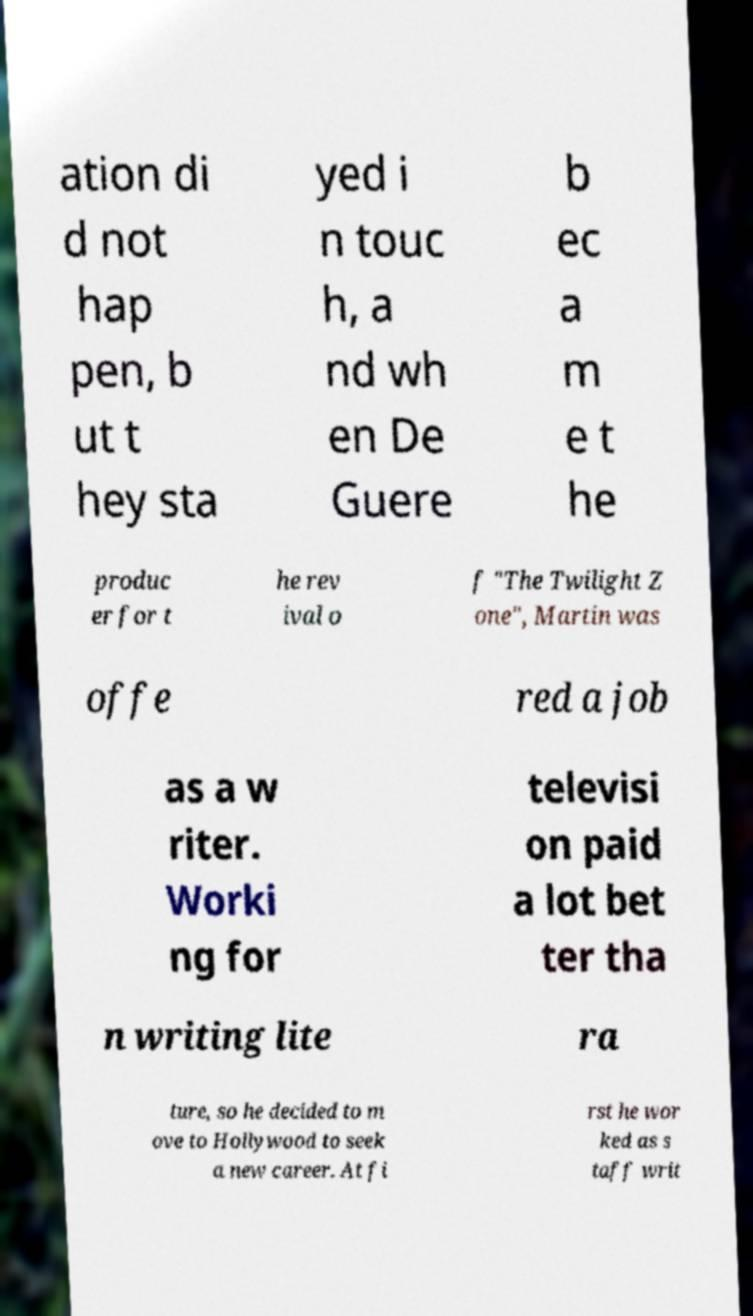Could you assist in decoding the text presented in this image and type it out clearly? ation di d not hap pen, b ut t hey sta yed i n touc h, a nd wh en De Guere b ec a m e t he produc er for t he rev ival o f "The Twilight Z one", Martin was offe red a job as a w riter. Worki ng for televisi on paid a lot bet ter tha n writing lite ra ture, so he decided to m ove to Hollywood to seek a new career. At fi rst he wor ked as s taff writ 